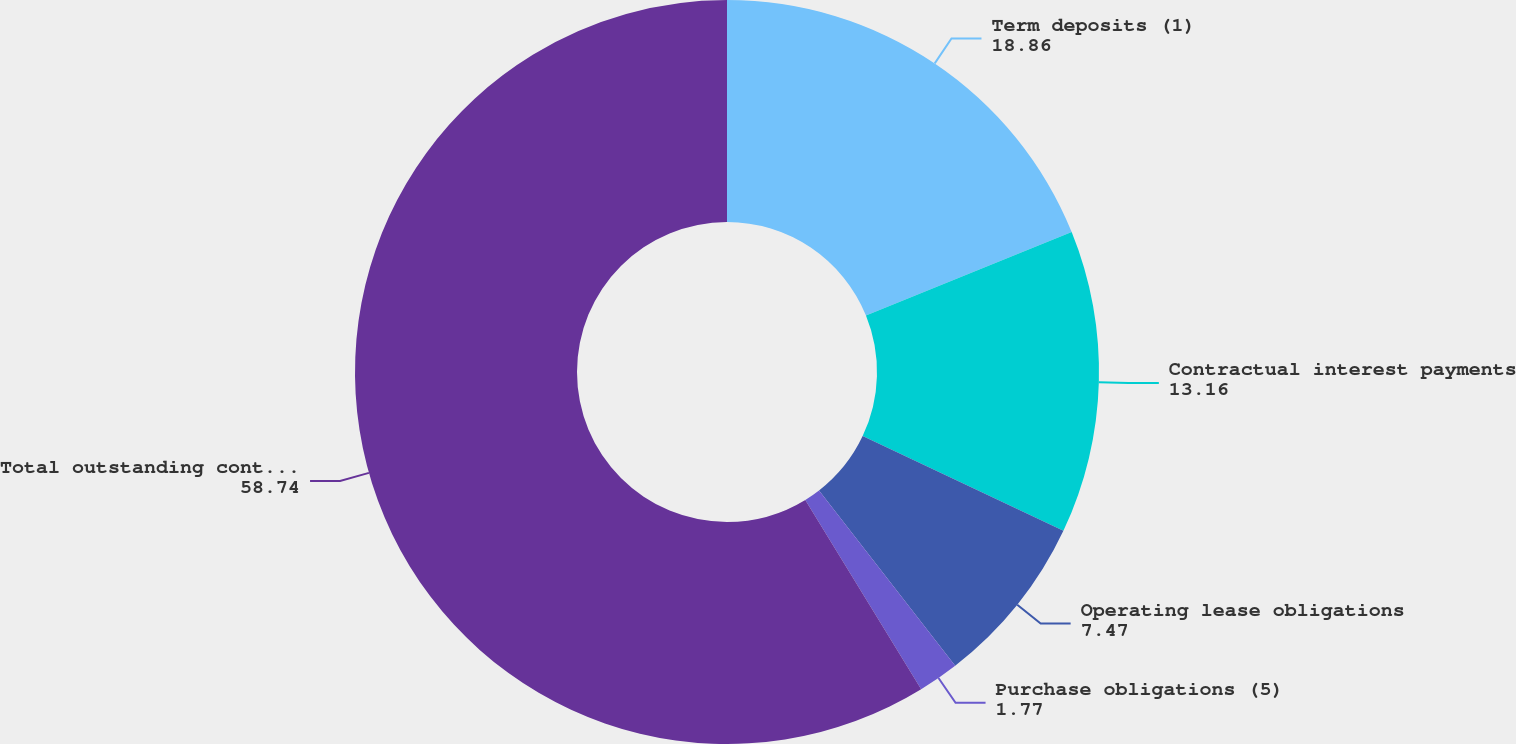<chart> <loc_0><loc_0><loc_500><loc_500><pie_chart><fcel>Term deposits (1)<fcel>Contractual interest payments<fcel>Operating lease obligations<fcel>Purchase obligations (5)<fcel>Total outstanding contractual<nl><fcel>18.86%<fcel>13.16%<fcel>7.47%<fcel>1.77%<fcel>58.74%<nl></chart> 